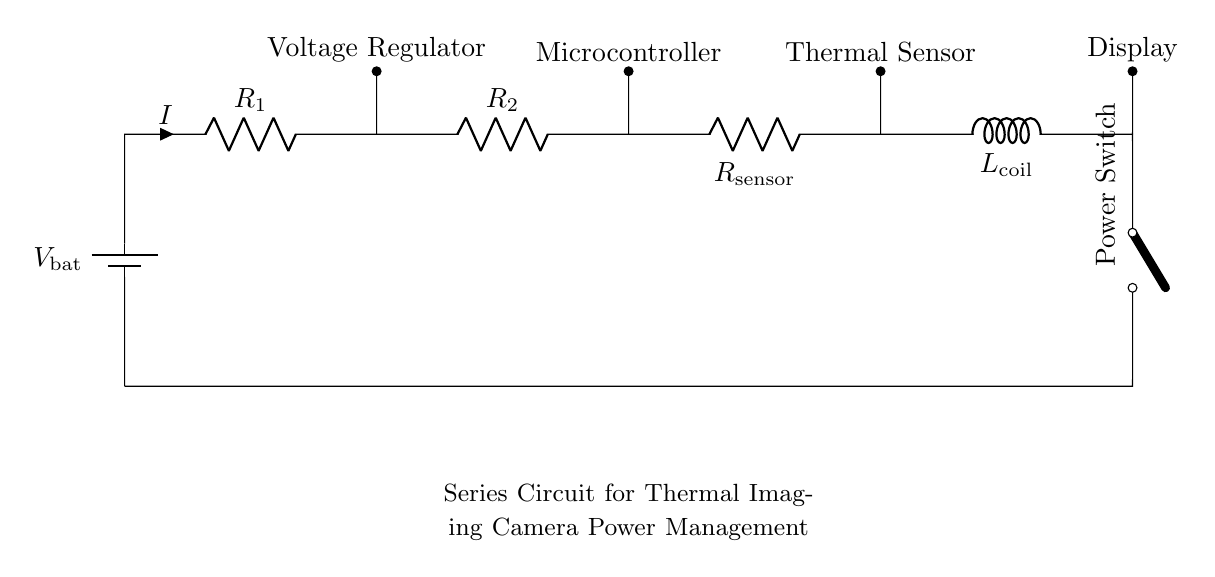What is the total resistance in the circuit? The total resistance in a series circuit is the sum of individual resistances. Here, R_1, R_2, and R_sensor are in series. Therefore, the total resistance R_total = R_1 + R_2 + R_sensor.
Answer: R_1 + R_2 + R_sensor Where is the voltage regulator located? The voltage regulator is shown directly above the resistor R_1 in the circuit diagram. It is connected in parallel to the resistor R_1.
Answer: Above R_1 What component controls the flow of current when off? In this series circuit, the component that controls the flow of current when it is off is the power switch. In the "off" position, it breaks the circuit.
Answer: Power switch How many resistors are in the circuit? The circuit contains three resistors: R_1, R_2, and R_sensor. Since these components are all labeled as resistors in the diagram, we can count them directly.
Answer: Three What is the purpose of the thermal sensor? The thermal sensor is connected in series and is responsible for detecting temperature variations, contributing to thermal imaging.
Answer: Detecting temperature Why is the display connected after the coil? In a series circuit, the order of components affects the current flow. The display is connected after the coil to show the thermal imaging results processed by previous components in the circuit.
Answer: To show thermal imaging results 